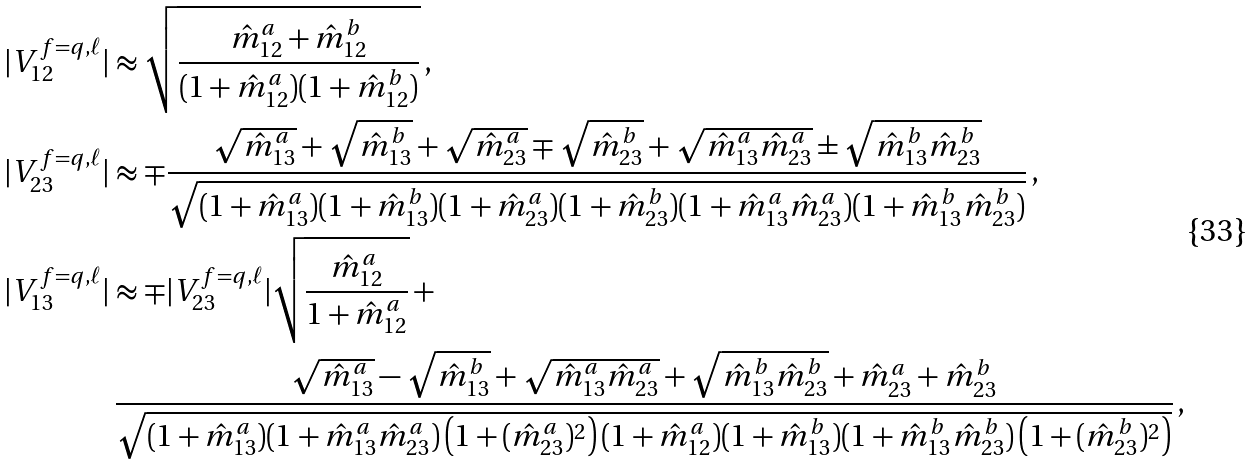<formula> <loc_0><loc_0><loc_500><loc_500>| V _ { 1 2 } ^ { f = q , \ell } | & \approx \sqrt { \frac { \hat { m } ^ { a } _ { 1 2 } + \hat { m } ^ { b } _ { 1 2 } } { ( 1 + \hat { m } ^ { a } _ { 1 2 } ) ( 1 + \hat { m } ^ { b } _ { 1 2 } ) } } \, , \\ | V ^ { f = q , \ell } _ { 2 3 } | & \approx \mp \frac { \sqrt { \hat { m } _ { 1 3 } ^ { a } } + \sqrt { \hat { m } _ { 1 3 } ^ { b } } + \sqrt { \hat { m } _ { 2 3 } ^ { a } } \mp \sqrt { \hat { m } _ { 2 3 } ^ { b } } + \sqrt { \hat { m } _ { 1 3 } ^ { a } \hat { m } _ { 2 3 } ^ { a } } \pm \sqrt { \hat { m } _ { 1 3 } ^ { b } \hat { m } _ { 2 3 } ^ { b } } } { \sqrt { ( 1 + \hat { m } _ { 1 3 } ^ { a } ) ( 1 + \hat { m } _ { 1 3 } ^ { b } ) ( 1 + \hat { m } _ { 2 3 } ^ { a } ) ( 1 + \hat { m } _ { 2 3 } ^ { b } ) ( 1 + \hat { m } _ { 1 3 } ^ { a } \hat { m } _ { 2 3 } ^ { a } ) ( 1 + \hat { m } _ { 1 3 } ^ { b } \hat { m } _ { 2 3 } ^ { b } ) } } \, , \\ | V _ { 1 3 } ^ { f = q , \ell } | & \approx \mp | V _ { 2 3 } ^ { f = q , \ell } | \sqrt { \frac { \hat { m } _ { 1 2 } ^ { a } } { 1 + \hat { m } _ { 1 2 } ^ { a } } } \, + \\ & \, \frac { \sqrt { \hat { m } ^ { a } _ { 1 3 } } - \sqrt { \hat { m } ^ { b } _ { 1 3 } } + \sqrt { \hat { m } ^ { a } _ { 1 3 } \hat { m } ^ { a } _ { 2 3 } } + \sqrt { \hat { m } ^ { b } _ { 1 3 } \hat { m } ^ { b } _ { 2 3 } } + \hat { m } ^ { a } _ { 2 3 } + \hat { m } ^ { b } _ { 2 3 } } { \sqrt { ( 1 + \hat { m } _ { 1 3 } ^ { a } ) ( 1 + \hat { m } _ { 1 3 } ^ { a } \hat { m } _ { 2 3 } ^ { a } ) \left ( 1 + ( \hat { m } _ { 2 3 } ^ { a } ) ^ { 2 } \right ) ( 1 + \hat { m } _ { 1 2 } ^ { a } ) ( 1 + \hat { m } ^ { b } _ { 1 3 } ) ( 1 + \hat { m } ^ { b } _ { 1 3 } \hat { m } ^ { b } _ { 2 3 } ) \left ( 1 + ( \hat { m } ^ { b } _ { 2 3 } ) ^ { 2 } \right ) } } \, ,</formula> 